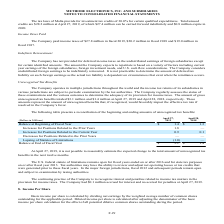From Methode Electronics's financial document, What was the amount of gross unrecognized tax benefits in 2019 and 2018 respectively? The document shows two values: $3.1 million and $1.4 million. From the document: "unrecognized tax benefits totaled $3.1 million and $1.4 million at April 27, 2019 and April 28, 2018, respectively. These amounts represent the amount..." Also, What was the accrued interest in 2019? According to the financial document, $0.1 million. The relevant text states: "provision for income taxes. The Company had $0.1 million accrued for interest and no accrual for penalties at April 27, 2019. 8. Income Per Share..." Also, What was the Balance at Beginning of Fiscal Year in 2019? According to the financial document, 1.4 (in millions). The relevant text states: "recognized tax benefits totaled $3.1 million and $1.4 million at April 27, 2019 and April 28, 2018, respectively. These amounts represent the amount of u..." Also, can you calculate: What was the change in the Balance at Beginning of Fiscal Year from 2018 to 2019? Based on the calculation: 1.4 - 1.3, the result is 0.1 (in millions). This is based on the information: "recognized tax benefits totaled $3.1 million and $1.4 million at April 27, 2019 and April 28, 2018, respectively. These amounts represent the amount of u Balance at Beginning of Fiscal Year $ 1.4 $ 1...." The key data points involved are: 1.3, 1.4. Also, can you calculate: What was the average Increases for Positions Related to the Prior Year for 2018 and 2019? To answer this question, I need to perform calculations using the financial data. The calculation is: (1.8 + 0) / 2, which equals 0.9 (in millions). This is based on the information: "ncreases for Positions Related to the Prior Years 1.8 — of Malta provide for investment tax credits of 30.0% for certain qualified expenditures. Total unused..." The key data points involved are: 1.8. Additionally, In which year was Balance at End of Fiscal Year less than 2.0 million? According to the financial document, 2018. The relevant text states: "8 million in fiscal 2019, $20.2 million in fiscal 2018 and $19.0 million in..." 